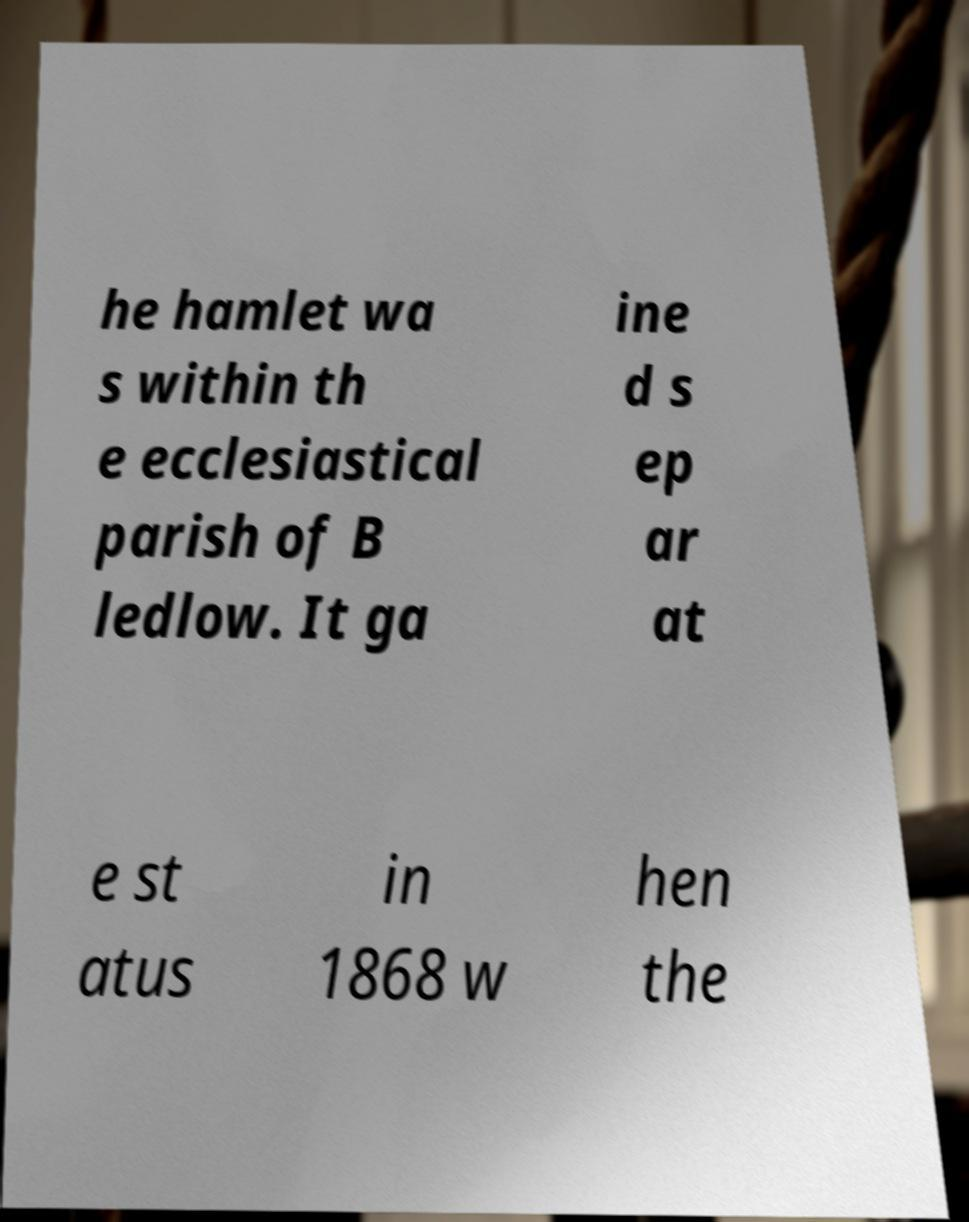There's text embedded in this image that I need extracted. Can you transcribe it verbatim? he hamlet wa s within th e ecclesiastical parish of B ledlow. It ga ine d s ep ar at e st atus in 1868 w hen the 